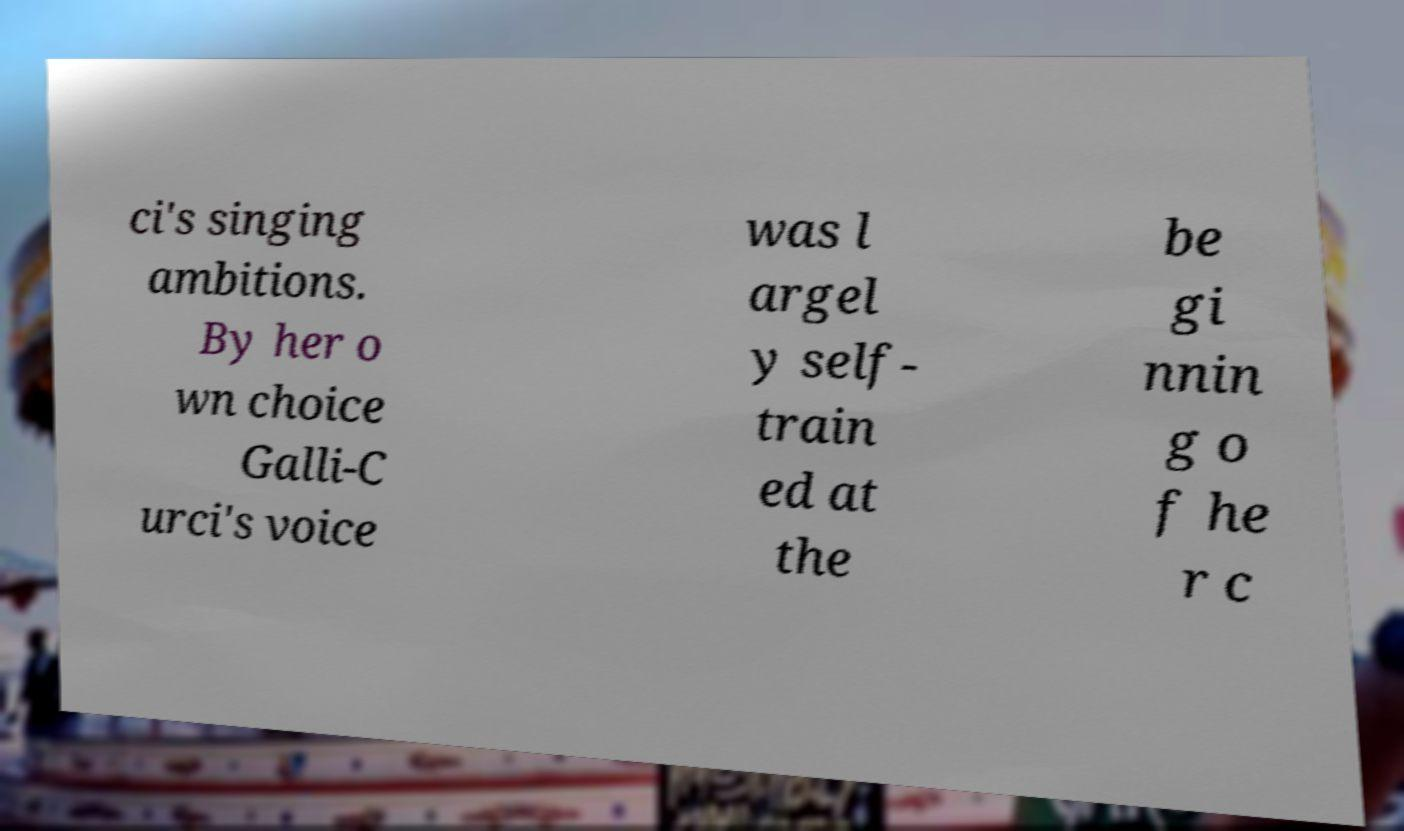Please identify and transcribe the text found in this image. ci's singing ambitions. By her o wn choice Galli-C urci's voice was l argel y self- train ed at the be gi nnin g o f he r c 